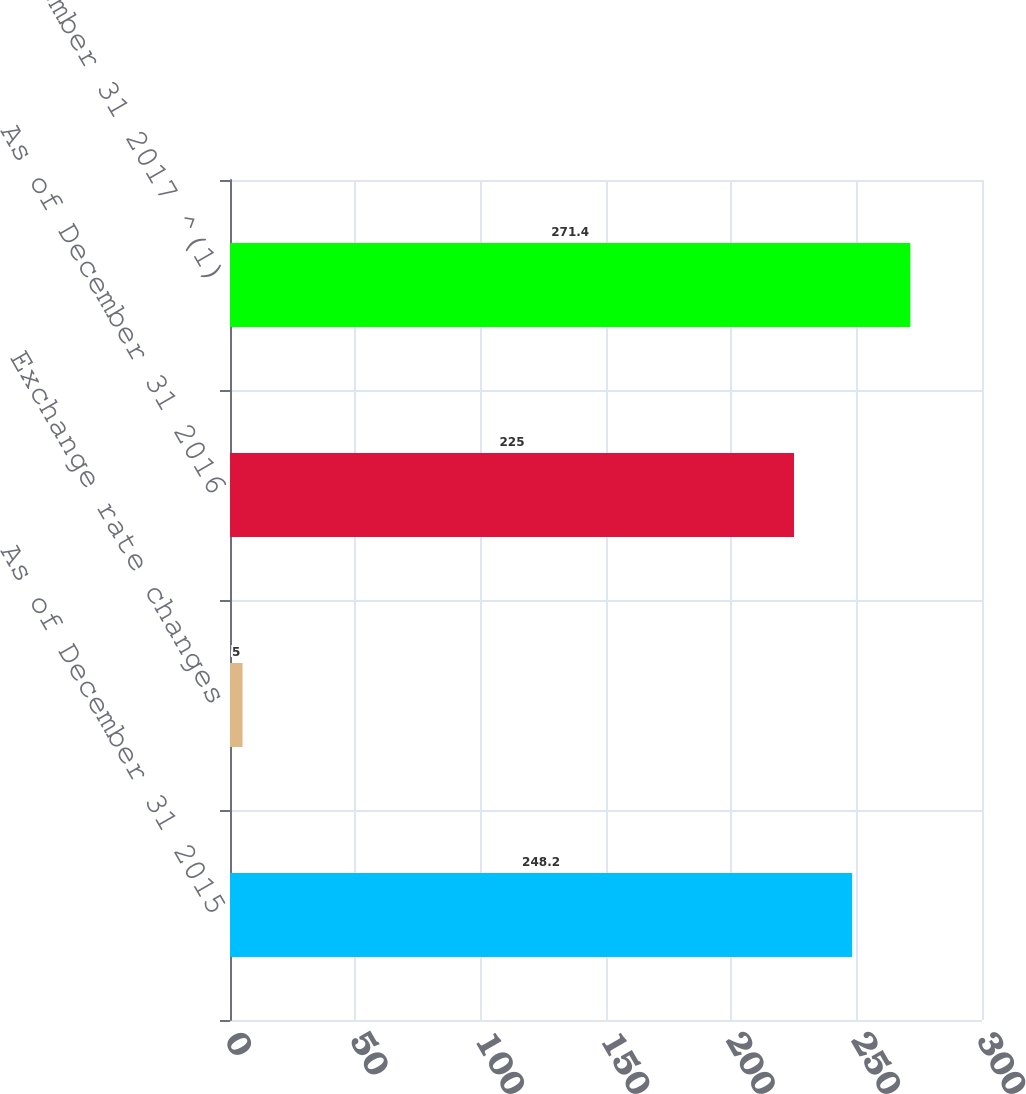Convert chart. <chart><loc_0><loc_0><loc_500><loc_500><bar_chart><fcel>As of December 31 2015<fcel>Exchange rate changes<fcel>As of December 31 2016<fcel>As of December 31 2017 ^(1)<nl><fcel>248.2<fcel>5<fcel>225<fcel>271.4<nl></chart> 